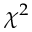<formula> <loc_0><loc_0><loc_500><loc_500>\chi ^ { 2 }</formula> 